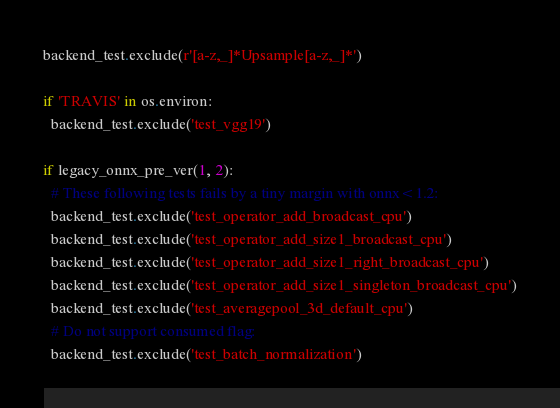<code> <loc_0><loc_0><loc_500><loc_500><_Python_>backend_test.exclude(r'[a-z,_]*Upsample[a-z,_]*')

if 'TRAVIS' in os.environ:
  backend_test.exclude('test_vgg19')

if legacy_onnx_pre_ver(1, 2):
  # These following tests fails by a tiny margin with onnx<1.2:
  backend_test.exclude('test_operator_add_broadcast_cpu')
  backend_test.exclude('test_operator_add_size1_broadcast_cpu')
  backend_test.exclude('test_operator_add_size1_right_broadcast_cpu')
  backend_test.exclude('test_operator_add_size1_singleton_broadcast_cpu')
  backend_test.exclude('test_averagepool_3d_default_cpu')
  # Do not support consumed flag:
  backend_test.exclude('test_batch_normalization')</code> 